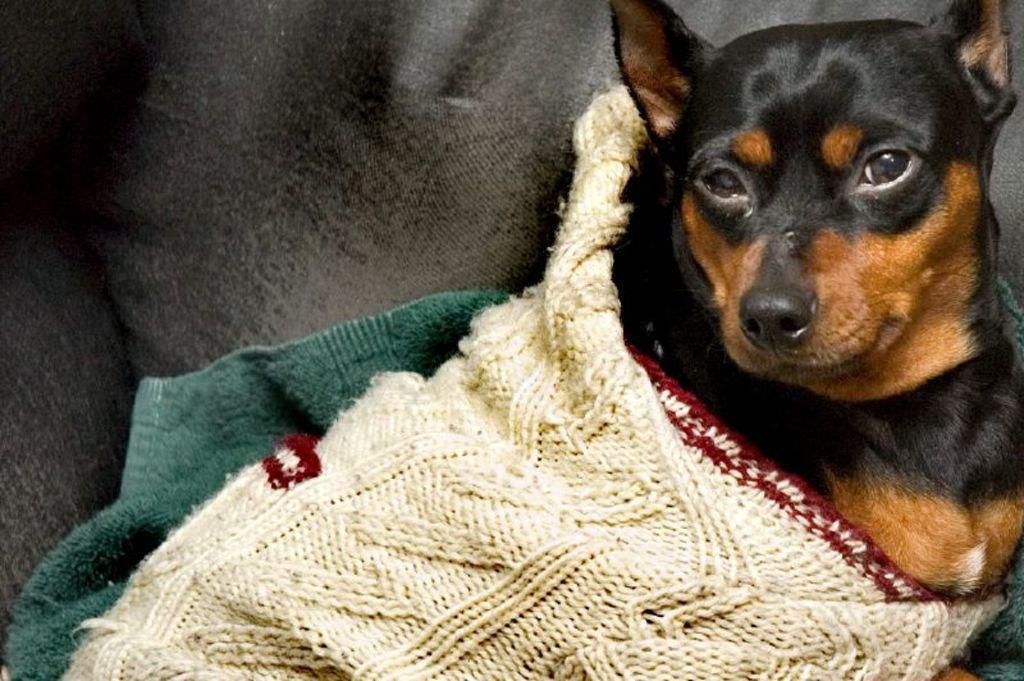Please provide a concise description of this image. In this picture we can see a dog and beside this dog we can see clothes. 